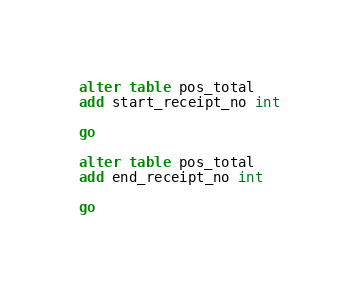<code> <loc_0><loc_0><loc_500><loc_500><_SQL_>alter table pos_total
add start_receipt_no int

go 

alter table pos_total
add end_receipt_no int

go



</code> 